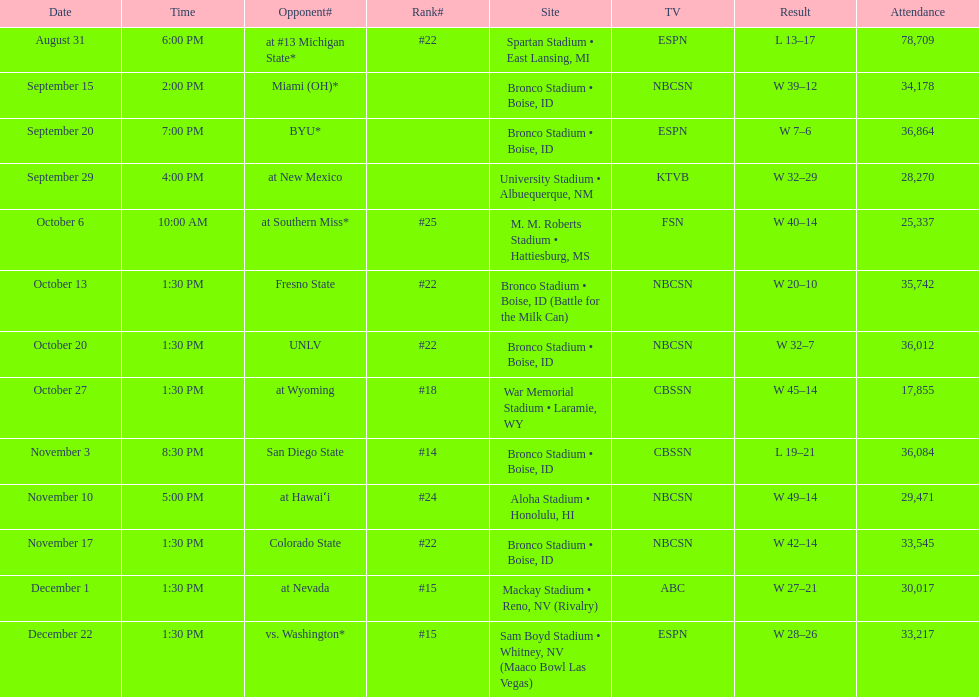Can you parse all the data within this table? {'header': ['Date', 'Time', 'Opponent#', 'Rank#', 'Site', 'TV', 'Result', 'Attendance'], 'rows': [['August 31', '6:00 PM', 'at\xa0#13\xa0Michigan State*', '#22', 'Spartan Stadium • East Lansing, MI', 'ESPN', 'L\xa013–17', '78,709'], ['September 15', '2:00 PM', 'Miami (OH)*', '', 'Bronco Stadium • Boise, ID', 'NBCSN', 'W\xa039–12', '34,178'], ['September 20', '7:00 PM', 'BYU*', '', 'Bronco Stadium • Boise, ID', 'ESPN', 'W\xa07–6', '36,864'], ['September 29', '4:00 PM', 'at\xa0New Mexico', '', 'University Stadium • Albuequerque, NM', 'KTVB', 'W\xa032–29', '28,270'], ['October 6', '10:00 AM', 'at\xa0Southern Miss*', '#25', 'M. M. Roberts Stadium • Hattiesburg, MS', 'FSN', 'W\xa040–14', '25,337'], ['October 13', '1:30 PM', 'Fresno State', '#22', 'Bronco Stadium • Boise, ID (Battle for the Milk Can)', 'NBCSN', 'W\xa020–10', '35,742'], ['October 20', '1:30 PM', 'UNLV', '#22', 'Bronco Stadium • Boise, ID', 'NBCSN', 'W\xa032–7', '36,012'], ['October 27', '1:30 PM', 'at\xa0Wyoming', '#18', 'War Memorial Stadium • Laramie, WY', 'CBSSN', 'W\xa045–14', '17,855'], ['November 3', '8:30 PM', 'San Diego State', '#14', 'Bronco Stadium • Boise, ID', 'CBSSN', 'L\xa019–21', '36,084'], ['November 10', '5:00 PM', 'at\xa0Hawaiʻi', '#24', 'Aloha Stadium • Honolulu, HI', 'NBCSN', 'W\xa049–14', '29,471'], ['November 17', '1:30 PM', 'Colorado State', '#22', 'Bronco Stadium • Boise, ID', 'NBCSN', 'W\xa042–14', '33,545'], ['December 1', '1:30 PM', 'at\xa0Nevada', '#15', 'Mackay Stadium • Reno, NV (Rivalry)', 'ABC', 'W\xa027–21', '30,017'], ['December 22', '1:30 PM', 'vs.\xa0Washington*', '#15', 'Sam Boyd Stadium • Whitney, NV (Maaco Bowl Las Vegas)', 'ESPN', 'W\xa028–26', '33,217']]} What was the highest number of consecutive victories achieved by the team during the season? 7. 